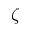<formula> <loc_0><loc_0><loc_500><loc_500>\zeta</formula> 